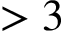<formula> <loc_0><loc_0><loc_500><loc_500>> 3</formula> 